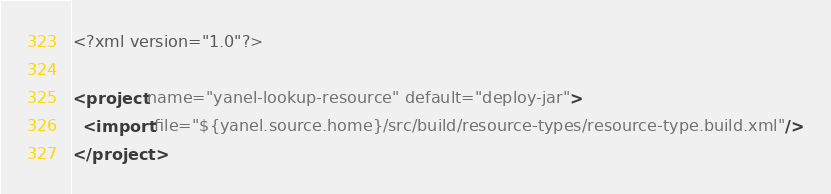<code> <loc_0><loc_0><loc_500><loc_500><_XML_><?xml version="1.0"?>

<project name="yanel-lookup-resource" default="deploy-jar">
  <import file="${yanel.source.home}/src/build/resource-types/resource-type.build.xml"/>
</project>
</code> 